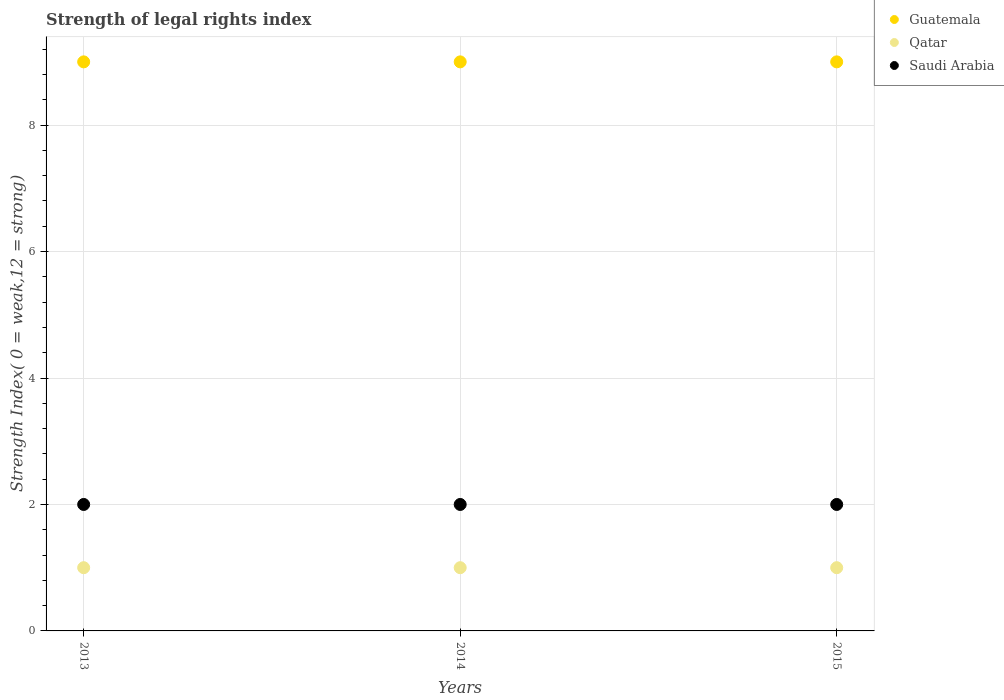How many different coloured dotlines are there?
Offer a very short reply. 3. Is the number of dotlines equal to the number of legend labels?
Ensure brevity in your answer.  Yes. What is the strength index in Saudi Arabia in 2013?
Your answer should be compact. 2. Across all years, what is the maximum strength index in Qatar?
Give a very brief answer. 1. Across all years, what is the minimum strength index in Qatar?
Your response must be concise. 1. In which year was the strength index in Guatemala maximum?
Offer a very short reply. 2013. What is the total strength index in Guatemala in the graph?
Make the answer very short. 27. What is the difference between the strength index in Guatemala in 2013 and that in 2015?
Provide a succinct answer. 0. What is the difference between the strength index in Qatar in 2015 and the strength index in Guatemala in 2014?
Provide a short and direct response. -8. What is the average strength index in Qatar per year?
Provide a short and direct response. 1. In the year 2015, what is the difference between the strength index in Guatemala and strength index in Qatar?
Your answer should be compact. 8. Is the strength index in Qatar in 2014 less than that in 2015?
Make the answer very short. No. What is the difference between the highest and the second highest strength index in Qatar?
Give a very brief answer. 0. Is the sum of the strength index in Saudi Arabia in 2014 and 2015 greater than the maximum strength index in Guatemala across all years?
Ensure brevity in your answer.  No. Does the strength index in Qatar monotonically increase over the years?
Offer a terse response. No. How many dotlines are there?
Offer a terse response. 3. Are the values on the major ticks of Y-axis written in scientific E-notation?
Provide a short and direct response. No. Does the graph contain any zero values?
Your answer should be compact. No. Does the graph contain grids?
Provide a short and direct response. Yes. Where does the legend appear in the graph?
Offer a terse response. Top right. How many legend labels are there?
Your response must be concise. 3. What is the title of the graph?
Ensure brevity in your answer.  Strength of legal rights index. What is the label or title of the Y-axis?
Your answer should be very brief. Strength Index( 0 = weak,12 = strong). What is the Strength Index( 0 = weak,12 = strong) in Qatar in 2013?
Ensure brevity in your answer.  1. What is the Strength Index( 0 = weak,12 = strong) of Saudi Arabia in 2013?
Make the answer very short. 2. What is the Strength Index( 0 = weak,12 = strong) of Qatar in 2014?
Provide a succinct answer. 1. What is the Strength Index( 0 = weak,12 = strong) in Guatemala in 2015?
Your response must be concise. 9. Across all years, what is the maximum Strength Index( 0 = weak,12 = strong) in Guatemala?
Ensure brevity in your answer.  9. Across all years, what is the maximum Strength Index( 0 = weak,12 = strong) of Qatar?
Provide a succinct answer. 1. Across all years, what is the maximum Strength Index( 0 = weak,12 = strong) in Saudi Arabia?
Give a very brief answer. 2. Across all years, what is the minimum Strength Index( 0 = weak,12 = strong) in Guatemala?
Your answer should be compact. 9. Across all years, what is the minimum Strength Index( 0 = weak,12 = strong) of Qatar?
Offer a very short reply. 1. Across all years, what is the minimum Strength Index( 0 = weak,12 = strong) in Saudi Arabia?
Offer a terse response. 2. What is the total Strength Index( 0 = weak,12 = strong) in Guatemala in the graph?
Your response must be concise. 27. What is the total Strength Index( 0 = weak,12 = strong) in Saudi Arabia in the graph?
Offer a terse response. 6. What is the difference between the Strength Index( 0 = weak,12 = strong) in Guatemala in 2013 and that in 2014?
Offer a very short reply. 0. What is the difference between the Strength Index( 0 = weak,12 = strong) of Qatar in 2013 and that in 2014?
Offer a terse response. 0. What is the difference between the Strength Index( 0 = weak,12 = strong) of Saudi Arabia in 2013 and that in 2014?
Your answer should be very brief. 0. What is the difference between the Strength Index( 0 = weak,12 = strong) in Saudi Arabia in 2013 and that in 2015?
Offer a terse response. 0. What is the difference between the Strength Index( 0 = weak,12 = strong) of Guatemala in 2013 and the Strength Index( 0 = weak,12 = strong) of Qatar in 2014?
Offer a terse response. 8. What is the difference between the Strength Index( 0 = weak,12 = strong) in Qatar in 2013 and the Strength Index( 0 = weak,12 = strong) in Saudi Arabia in 2014?
Give a very brief answer. -1. What is the difference between the Strength Index( 0 = weak,12 = strong) of Guatemala in 2013 and the Strength Index( 0 = weak,12 = strong) of Qatar in 2015?
Give a very brief answer. 8. What is the difference between the Strength Index( 0 = weak,12 = strong) in Guatemala in 2013 and the Strength Index( 0 = weak,12 = strong) in Saudi Arabia in 2015?
Your response must be concise. 7. What is the difference between the Strength Index( 0 = weak,12 = strong) in Qatar in 2013 and the Strength Index( 0 = weak,12 = strong) in Saudi Arabia in 2015?
Give a very brief answer. -1. What is the difference between the Strength Index( 0 = weak,12 = strong) of Guatemala in 2014 and the Strength Index( 0 = weak,12 = strong) of Saudi Arabia in 2015?
Your answer should be very brief. 7. What is the difference between the Strength Index( 0 = weak,12 = strong) of Qatar in 2014 and the Strength Index( 0 = weak,12 = strong) of Saudi Arabia in 2015?
Give a very brief answer. -1. What is the average Strength Index( 0 = weak,12 = strong) in Guatemala per year?
Your answer should be very brief. 9. In the year 2013, what is the difference between the Strength Index( 0 = weak,12 = strong) of Guatemala and Strength Index( 0 = weak,12 = strong) of Saudi Arabia?
Offer a very short reply. 7. In the year 2014, what is the difference between the Strength Index( 0 = weak,12 = strong) in Guatemala and Strength Index( 0 = weak,12 = strong) in Saudi Arabia?
Provide a succinct answer. 7. In the year 2014, what is the difference between the Strength Index( 0 = weak,12 = strong) of Qatar and Strength Index( 0 = weak,12 = strong) of Saudi Arabia?
Your answer should be very brief. -1. What is the ratio of the Strength Index( 0 = weak,12 = strong) in Saudi Arabia in 2013 to that in 2014?
Offer a very short reply. 1. What is the ratio of the Strength Index( 0 = weak,12 = strong) of Qatar in 2013 to that in 2015?
Your answer should be compact. 1. What is the ratio of the Strength Index( 0 = weak,12 = strong) of Guatemala in 2014 to that in 2015?
Give a very brief answer. 1. What is the difference between the highest and the lowest Strength Index( 0 = weak,12 = strong) of Guatemala?
Offer a very short reply. 0. 